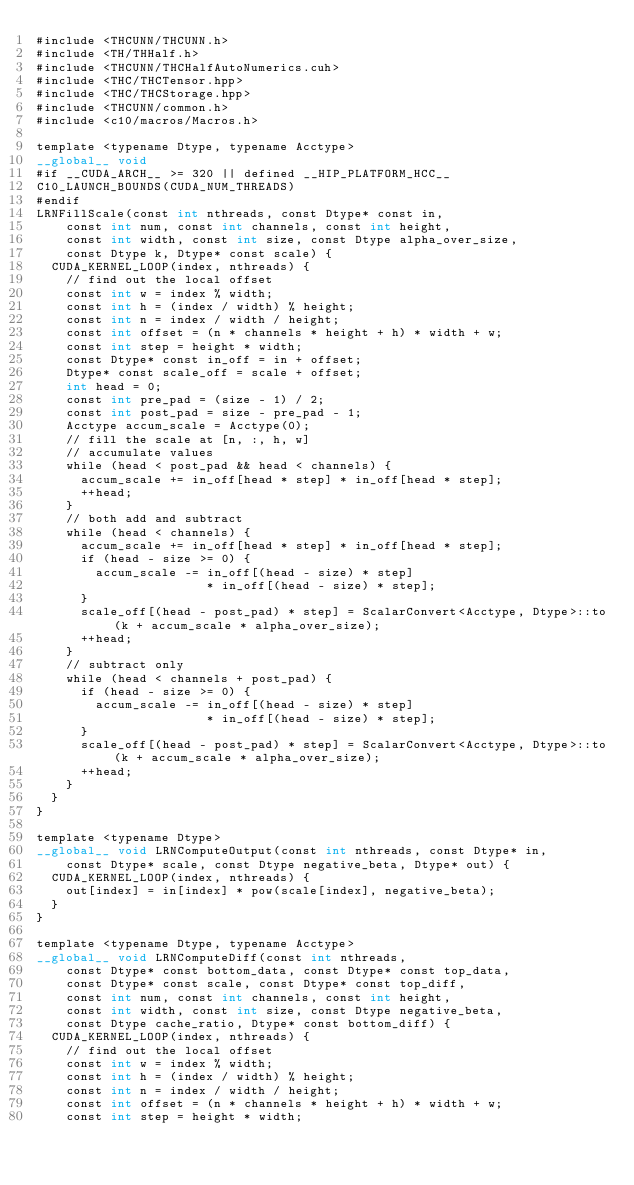Convert code to text. <code><loc_0><loc_0><loc_500><loc_500><_Cuda_>#include <THCUNN/THCUNN.h>
#include <TH/THHalf.h>
#include <THCUNN/THCHalfAutoNumerics.cuh>
#include <THC/THCTensor.hpp>
#include <THC/THCStorage.hpp>
#include <THCUNN/common.h>
#include <c10/macros/Macros.h>

template <typename Dtype, typename Acctype>
__global__ void
#if __CUDA_ARCH__ >= 320 || defined __HIP_PLATFORM_HCC__
C10_LAUNCH_BOUNDS(CUDA_NUM_THREADS)
#endif
LRNFillScale(const int nthreads, const Dtype* const in,
    const int num, const int channels, const int height,
    const int width, const int size, const Dtype alpha_over_size,
    const Dtype k, Dtype* const scale) {
  CUDA_KERNEL_LOOP(index, nthreads) {
    // find out the local offset
    const int w = index % width;
    const int h = (index / width) % height;
    const int n = index / width / height;
    const int offset = (n * channels * height + h) * width + w;
    const int step = height * width;
    const Dtype* const in_off = in + offset;
    Dtype* const scale_off = scale + offset;
    int head = 0;
    const int pre_pad = (size - 1) / 2;
    const int post_pad = size - pre_pad - 1;
    Acctype accum_scale = Acctype(0);
    // fill the scale at [n, :, h, w]
    // accumulate values
    while (head < post_pad && head < channels) {
      accum_scale += in_off[head * step] * in_off[head * step];
      ++head;
    }
    // both add and subtract
    while (head < channels) {
      accum_scale += in_off[head * step] * in_off[head * step];
      if (head - size >= 0) {
        accum_scale -= in_off[(head - size) * step]
                       * in_off[(head - size) * step];
      }
      scale_off[(head - post_pad) * step] = ScalarConvert<Acctype, Dtype>::to(k + accum_scale * alpha_over_size);
      ++head;
    }
    // subtract only
    while (head < channels + post_pad) {
      if (head - size >= 0) {
        accum_scale -= in_off[(head - size) * step]
                       * in_off[(head - size) * step];
      }
      scale_off[(head - post_pad) * step] = ScalarConvert<Acctype, Dtype>::to(k + accum_scale * alpha_over_size);
      ++head;
    }
  }
}

template <typename Dtype>
__global__ void LRNComputeOutput(const int nthreads, const Dtype* in,
    const Dtype* scale, const Dtype negative_beta, Dtype* out) {
  CUDA_KERNEL_LOOP(index, nthreads) {
    out[index] = in[index] * pow(scale[index], negative_beta);
  }
}

template <typename Dtype, typename Acctype>
__global__ void LRNComputeDiff(const int nthreads,
    const Dtype* const bottom_data, const Dtype* const top_data,
    const Dtype* const scale, const Dtype* const top_diff,
    const int num, const int channels, const int height,
    const int width, const int size, const Dtype negative_beta,
    const Dtype cache_ratio, Dtype* const bottom_diff) {
  CUDA_KERNEL_LOOP(index, nthreads) {
    // find out the local offset
    const int w = index % width;
    const int h = (index / width) % height;
    const int n = index / width / height;
    const int offset = (n * channels * height + h) * width + w;
    const int step = height * width;</code> 